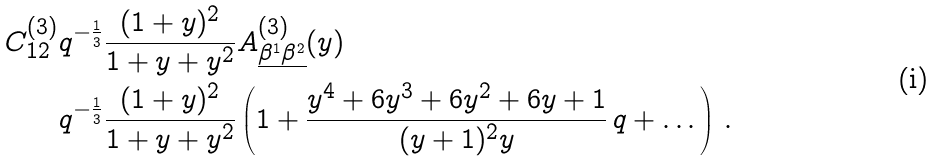<formula> <loc_0><loc_0><loc_500><loc_500>C ^ { ( 3 ) } _ { 1 2 } & q ^ { - \frac { 1 } { 3 } } \frac { ( 1 + y ) ^ { 2 } } { 1 + y + y ^ { 2 } } A ^ { ( 3 ) } _ { \underline { \beta ^ { 1 } \beta ^ { 2 } } } ( y ) \\ & q ^ { - \frac { 1 } { 3 } } \frac { ( 1 + y ) ^ { 2 } } { 1 + y + y ^ { 2 } } \left ( 1 + \frac { y ^ { 4 } + 6 y ^ { 3 } + 6 y ^ { 2 } + 6 y + 1 } { ( y + 1 ) ^ { 2 } y } \, q + \dots \right ) \, .</formula> 